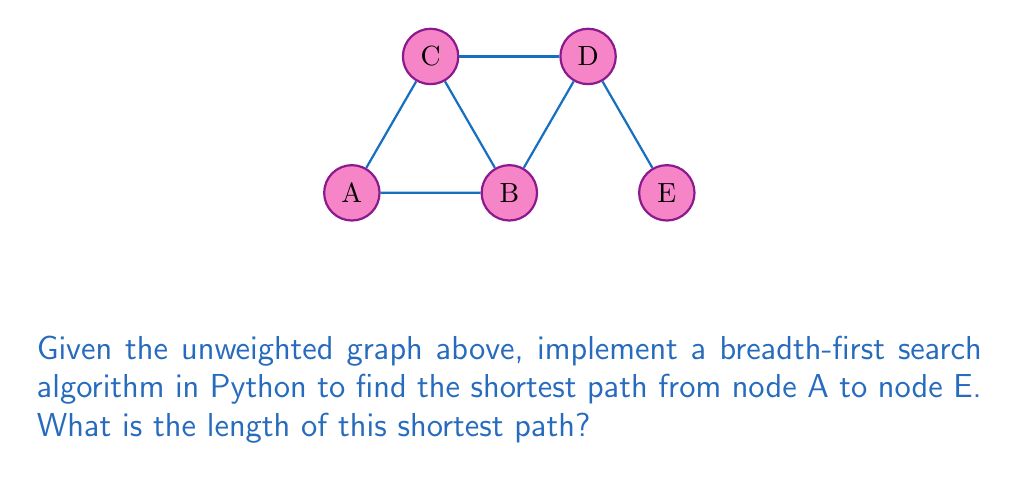Solve this math problem. To solve this problem using breadth-first search (BFS) in Python, we'll follow these steps:

1. Represent the graph as an adjacency list:
```python
graph = {
    'A': ['B', 'C'],
    'B': ['A', 'C', 'D'],
    'C': ['A', 'B', 'D'],
    'D': ['B', 'C', 'E'],
    'E': ['D']
}
```

2. Implement the BFS algorithm:
```python
from collections import deque

def bfs_shortest_path(graph, start, goal):
    queue = deque([[start]])
    visited = set([start])
    
    while queue:
        path = queue.popleft()
        node = path[-1]
        
        if node == goal:
            return path
        
        for neighbor in graph[node]:
            if neighbor not in visited:
                visited.add(neighbor)
                new_path = list(path)
                new_path.append(neighbor)
                queue.append(new_path)
    
    return None
```

3. Find the shortest path:
```python
shortest_path = bfs_shortest_path(graph, 'A', 'E')
```

4. Calculate the length of the shortest path:
```python
path_length = len(shortest_path) - 1 if shortest_path else -1
```

The BFS algorithm explores the graph level by level, ensuring that the first path found to the goal node is the shortest. In this case, the shortest path is A → B → D → E, which has a length of 3 edges.
Answer: 3 